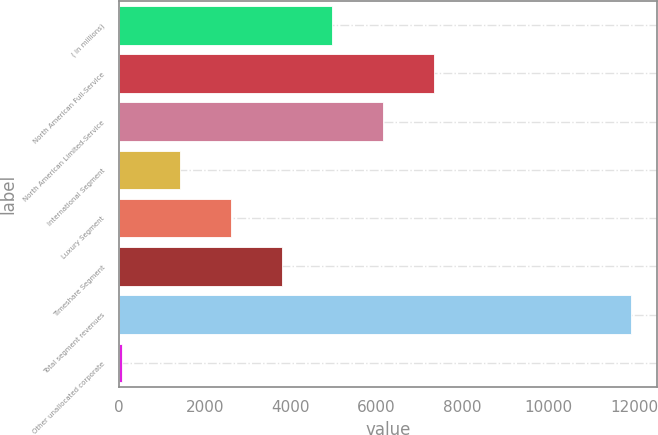<chart> <loc_0><loc_0><loc_500><loc_500><bar_chart><fcel>( in millions)<fcel>North American Full-Service<fcel>North American Limited-Service<fcel>International Segment<fcel>Luxury Segment<fcel>Timeshare Segment<fcel>Total segment revenues<fcel>Other unallocated corporate<nl><fcel>4970.5<fcel>7343.5<fcel>6157<fcel>1411<fcel>2597.5<fcel>3784<fcel>11930<fcel>65<nl></chart> 